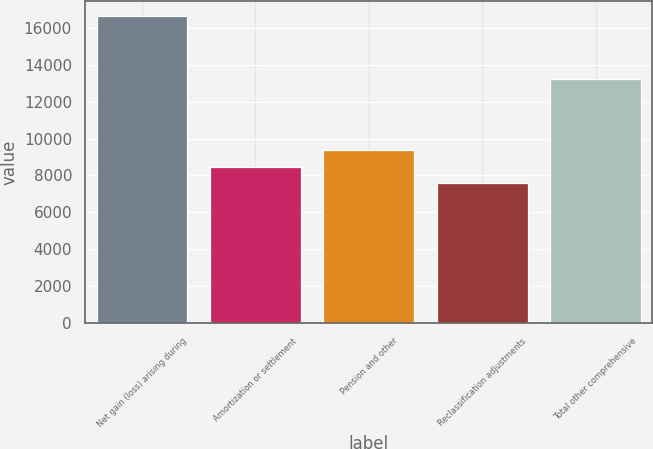Convert chart. <chart><loc_0><loc_0><loc_500><loc_500><bar_chart><fcel>Net gain (loss) arising during<fcel>Amortization or settlement<fcel>Pension and other<fcel>Reclassification adjustments<fcel>Total other comprehensive<nl><fcel>16607<fcel>8474.6<fcel>9378.2<fcel>7571<fcel>13210<nl></chart> 